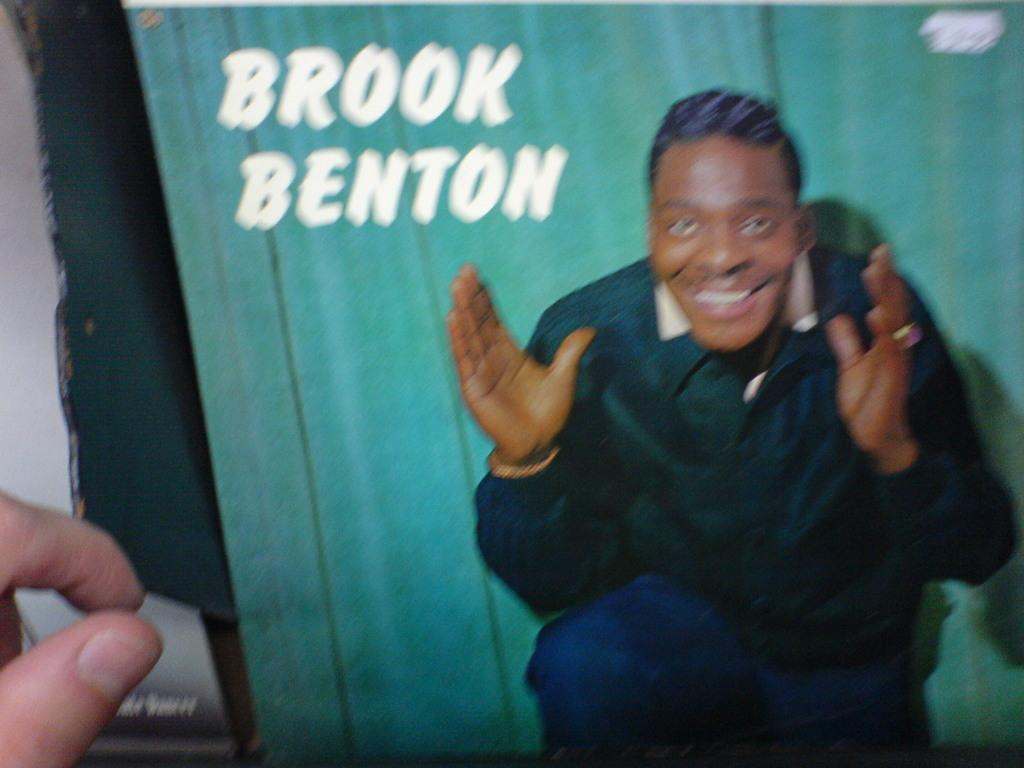What is featured on the poster in the image? The poster contains an image of a man. Is there any text on the poster? Yes, there is text on the poster. Can you describe the fingers visible on the left side of the image? The fingers of a person are visible on the left side of the image. Is the poster made of canvas in the image? The facts provided do not mention the material of the poster, so it cannot be determined if it is made of canvas. 